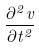<formula> <loc_0><loc_0><loc_500><loc_500>\frac { \partial ^ { 2 } v } { \partial t ^ { 2 } }</formula> 